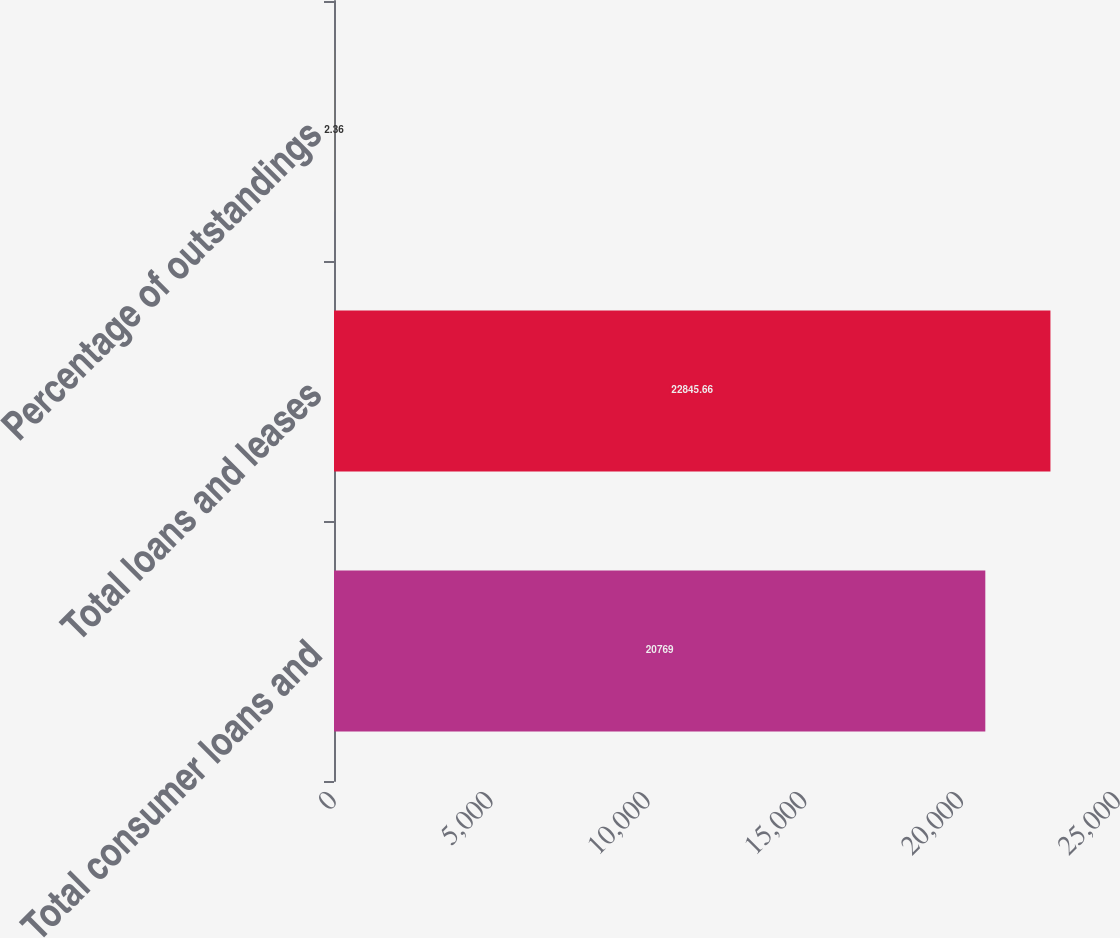<chart> <loc_0><loc_0><loc_500><loc_500><bar_chart><fcel>Total consumer loans and<fcel>Total loans and leases<fcel>Percentage of outstandings<nl><fcel>20769<fcel>22845.7<fcel>2.36<nl></chart> 